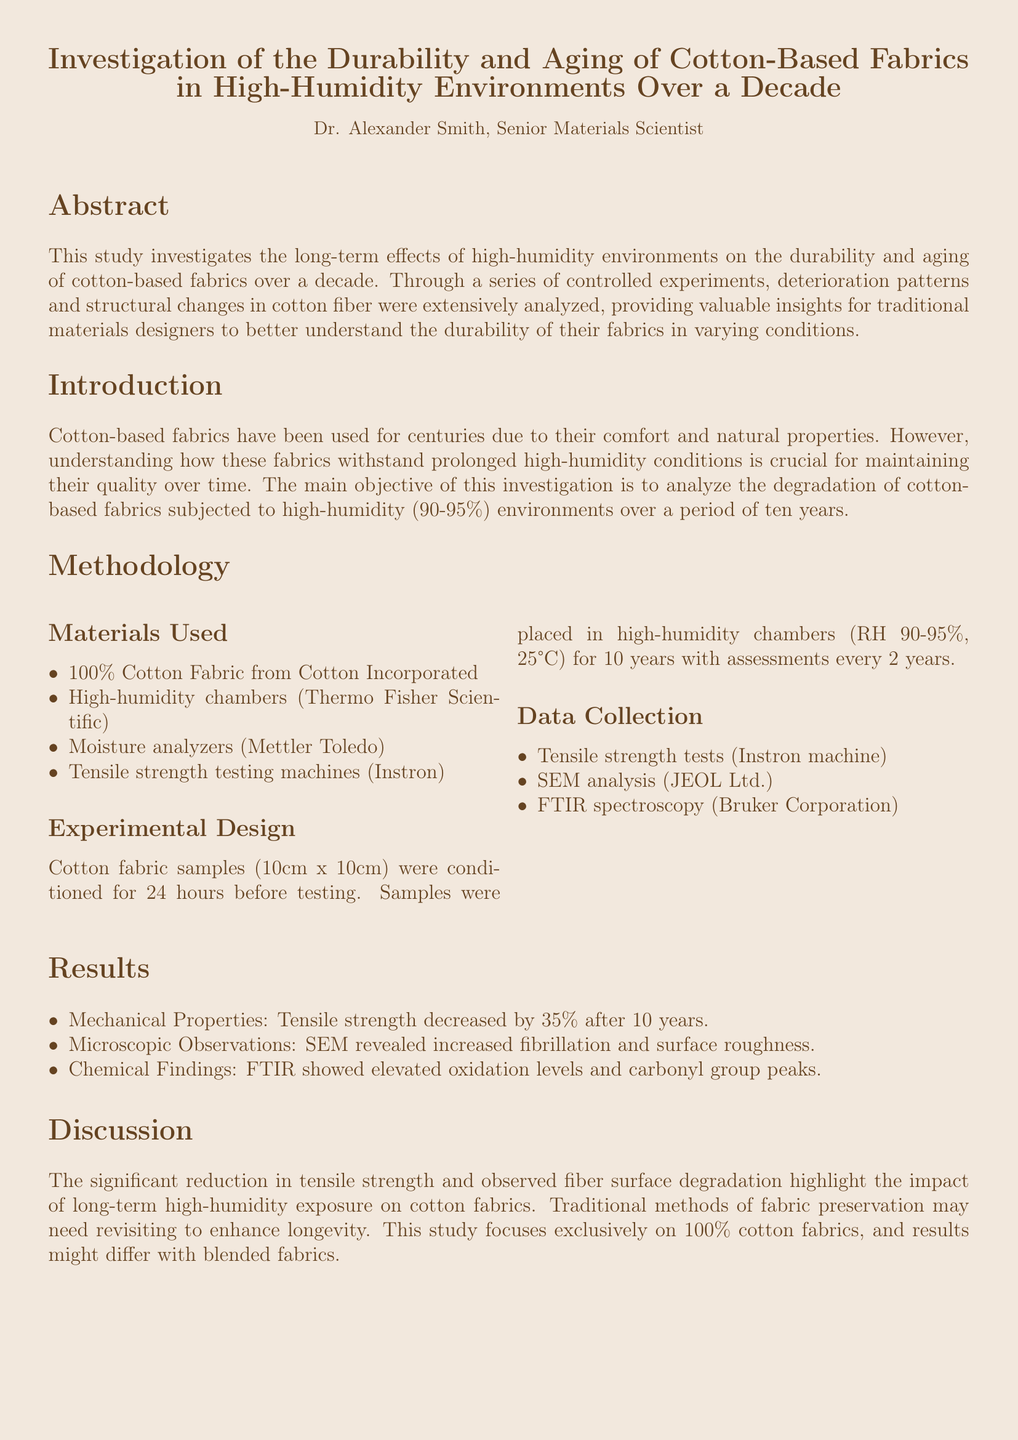What is the main objective of the investigation? The main objective is to analyze the degradation of cotton-based fabrics subjected to high-humidity environments over a period of ten years.
Answer: Analyze degradation Who conducted the study? The study was conducted by Dr. Alexander Smith, who is listed as a Senior Materials Scientist.
Answer: Dr. Alexander Smith What was the decrease in tensile strength after 10 years? The report states that the tensile strength decreased by 35% after 10 years.
Answer: 35% What environment conditions were the cotton fabric samples subjected to during the experiment? The cotton fabric samples were placed in environments with relative humidity of 90-95% and a temperature of 25°C.
Answer: 90-95% humidity, 25°C What type of microscopic analysis was performed on the fabric samples? Scanning Electron Microscope (SEM) analysis was performed on the fabric samples to observe deterioration patterns.
Answer: SEM analysis What was the period of assessment for the cotton fabric samples? The assessment of the cotton fabric samples was conducted every 2 years over a decade.
Answer: Every 2 years What are some of the materials used in the investigation? Materials used include 100% Cotton Fabric, high-humidity chambers, moisture analyzers, and tensile strength testing machines.
Answer: 100% Cotton Fabric, high-humidity chambers What key findings were observed in the chemical analysis? FTIR spectroscopy showed elevated oxidation levels and carbonyl group peaks in the cotton fabric samples.
Answer: Elevated oxidation levels, carbonyl group peaks What is suggested for traditional methods of fabric preservation based on the discussion? The discussion suggests that traditional methods of fabric preservation may need to be revisited to enhance longevity.
Answer: Need revisiting 